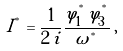Convert formula to latex. <formula><loc_0><loc_0><loc_500><loc_500>I ^ { ^ { * } } = \frac { 1 } { 2 \, i } \frac { \varphi ^ { ^ { * } } _ { 1 } \, \varphi ^ { ^ { * } } _ { 3 } } { \omega ^ { ^ { * } } } \, ,</formula> 